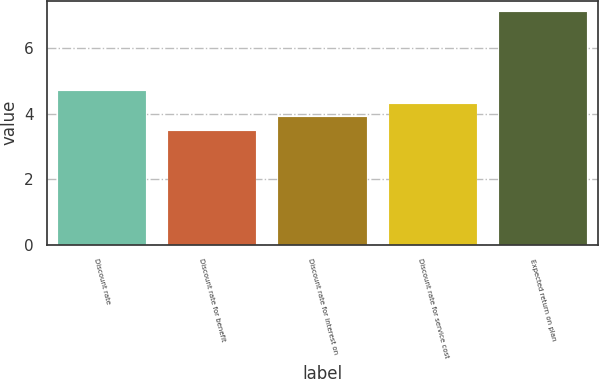Convert chart to OTSL. <chart><loc_0><loc_0><loc_500><loc_500><bar_chart><fcel>Discount rate<fcel>Discount rate for benefit<fcel>Discount rate for interest on<fcel>Discount rate for service cost<fcel>Expected return on plan<nl><fcel>4.68<fcel>3.48<fcel>3.88<fcel>4.28<fcel>7.08<nl></chart> 